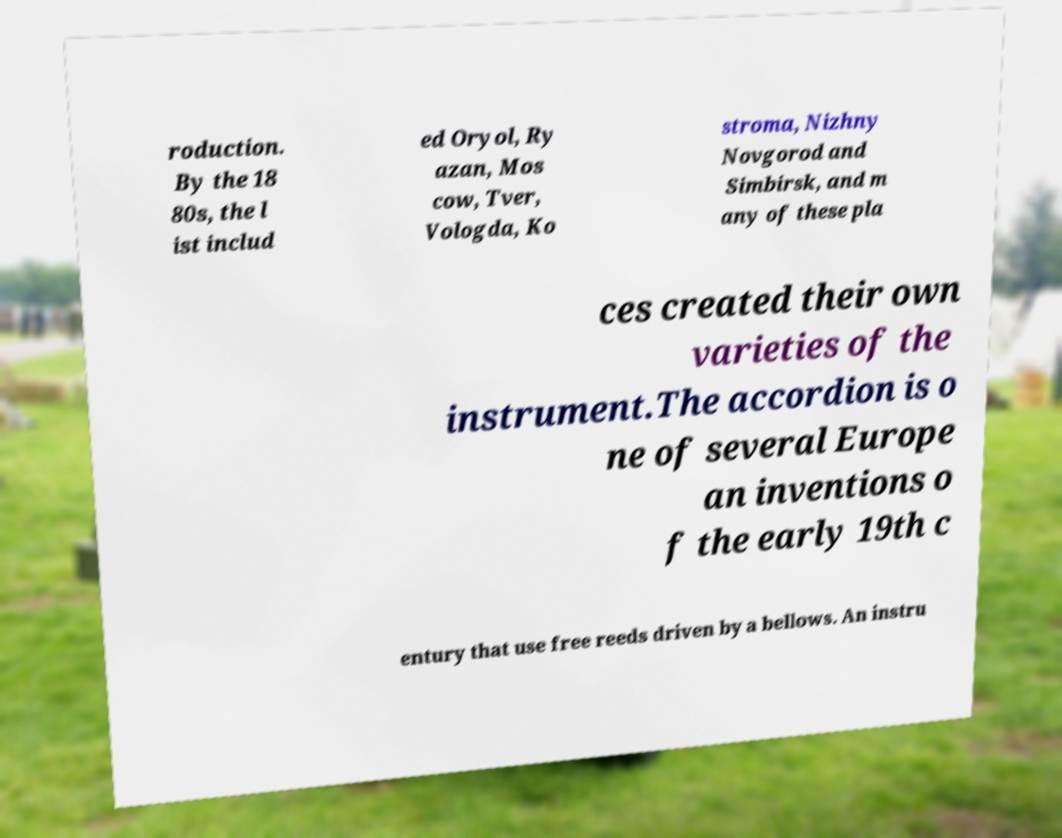I need the written content from this picture converted into text. Can you do that? roduction. By the 18 80s, the l ist includ ed Oryol, Ry azan, Mos cow, Tver, Vologda, Ko stroma, Nizhny Novgorod and Simbirsk, and m any of these pla ces created their own varieties of the instrument.The accordion is o ne of several Europe an inventions o f the early 19th c entury that use free reeds driven by a bellows. An instru 